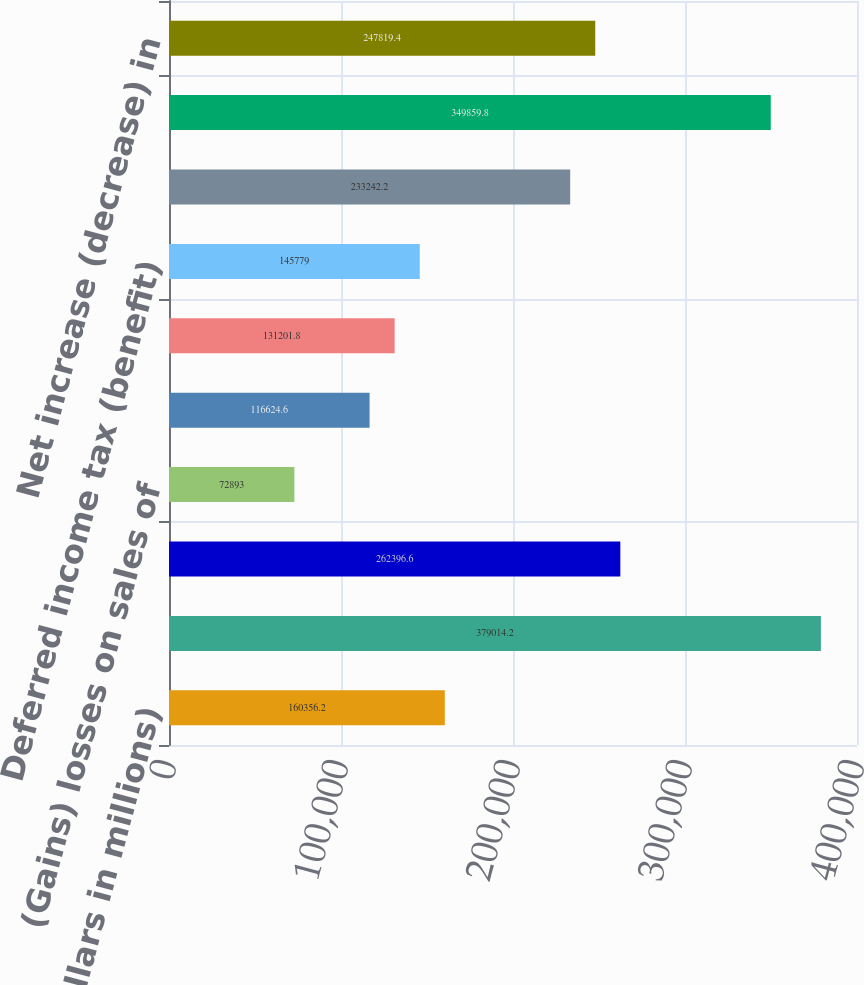<chart> <loc_0><loc_0><loc_500><loc_500><bar_chart><fcel>(Dollars in millions)<fcel>Net income<fcel>Provision for credit losses<fcel>(Gains) losses on sales of<fcel>Depreciation and premises<fcel>Amortization of intangibles<fcel>Deferred income tax (benefit)<fcel>Net increase in trading and<fcel>Net increase in other assets<fcel>Net increase (decrease) in<nl><fcel>160356<fcel>379014<fcel>262397<fcel>72893<fcel>116625<fcel>131202<fcel>145779<fcel>233242<fcel>349860<fcel>247819<nl></chart> 